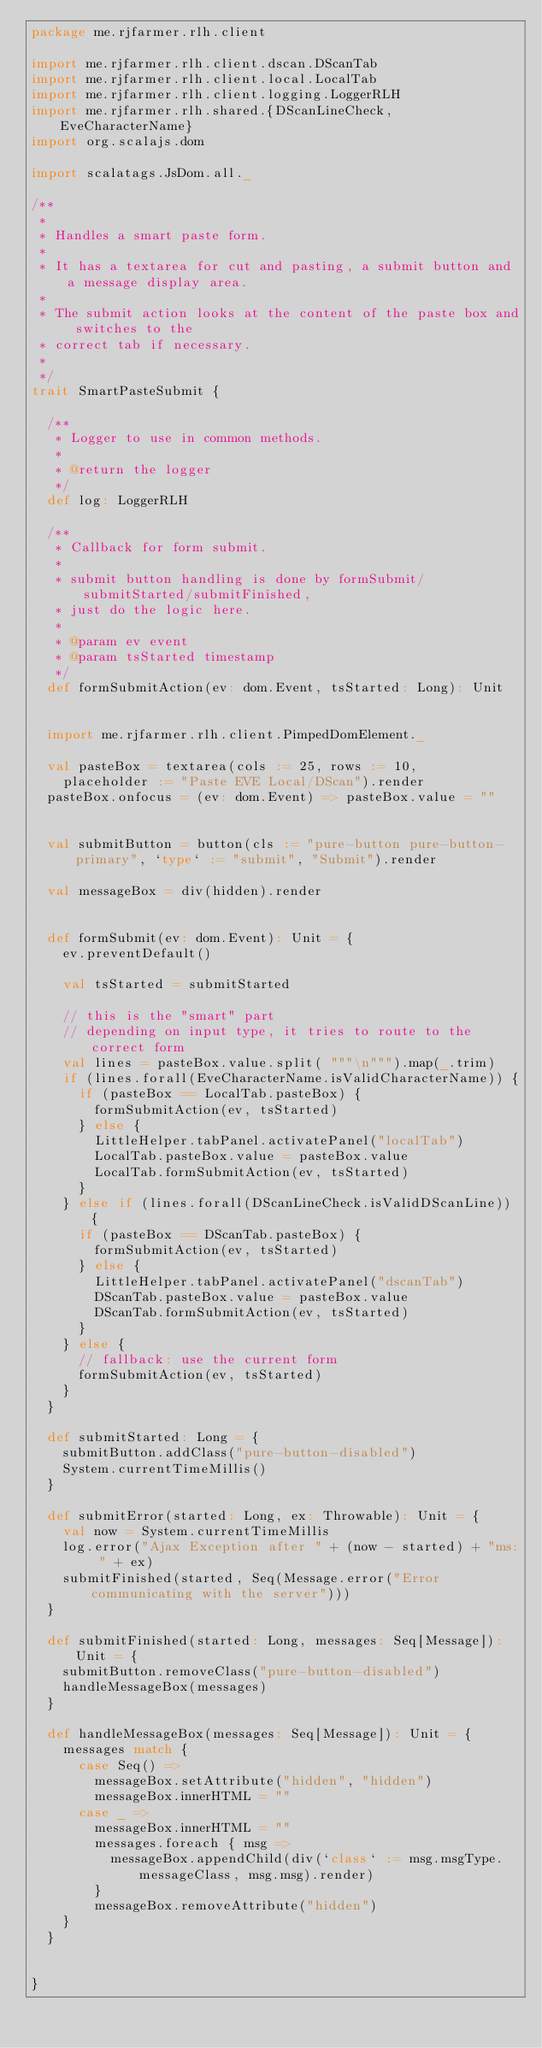<code> <loc_0><loc_0><loc_500><loc_500><_Scala_>package me.rjfarmer.rlh.client

import me.rjfarmer.rlh.client.dscan.DScanTab
import me.rjfarmer.rlh.client.local.LocalTab
import me.rjfarmer.rlh.client.logging.LoggerRLH
import me.rjfarmer.rlh.shared.{DScanLineCheck, EveCharacterName}
import org.scalajs.dom

import scalatags.JsDom.all._

/**
 *
 * Handles a smart paste form.
 *
 * It has a textarea for cut and pasting, a submit button and a message display area.
 *
 * The submit action looks at the content of the paste box and switches to the
 * correct tab if necessary.
 *
 */
trait SmartPasteSubmit {

  /**
   * Logger to use in common methods.
   *
   * @return the logger
   */
  def log: LoggerRLH

  /**
   * Callback for form submit.
   *
   * submit button handling is done by formSubmit/submitStarted/submitFinished,
   * just do the logic here.
   *
   * @param ev event
   * @param tsStarted timestamp
   */
  def formSubmitAction(ev: dom.Event, tsStarted: Long): Unit


  import me.rjfarmer.rlh.client.PimpedDomElement._

  val pasteBox = textarea(cols := 25, rows := 10,
    placeholder := "Paste EVE Local/DScan").render
  pasteBox.onfocus = (ev: dom.Event) => pasteBox.value = ""


  val submitButton = button(cls := "pure-button pure-button-primary", `type` := "submit", "Submit").render

  val messageBox = div(hidden).render


  def formSubmit(ev: dom.Event): Unit = {
    ev.preventDefault()

    val tsStarted = submitStarted

    // this is the "smart" part
    // depending on input type, it tries to route to the correct form
    val lines = pasteBox.value.split( """\n""").map(_.trim)
    if (lines.forall(EveCharacterName.isValidCharacterName)) {
      if (pasteBox == LocalTab.pasteBox) {
        formSubmitAction(ev, tsStarted)
      } else {
        LittleHelper.tabPanel.activatePanel("localTab")
        LocalTab.pasteBox.value = pasteBox.value
        LocalTab.formSubmitAction(ev, tsStarted)
      }
    } else if (lines.forall(DScanLineCheck.isValidDScanLine)) {
      if (pasteBox == DScanTab.pasteBox) {
        formSubmitAction(ev, tsStarted)
      } else {
        LittleHelper.tabPanel.activatePanel("dscanTab")
        DScanTab.pasteBox.value = pasteBox.value
        DScanTab.formSubmitAction(ev, tsStarted)
      }
    } else {
      // fallback: use the current form
      formSubmitAction(ev, tsStarted)
    }
  }

  def submitStarted: Long = {
    submitButton.addClass("pure-button-disabled")
    System.currentTimeMillis()
  }

  def submitError(started: Long, ex: Throwable): Unit = {
    val now = System.currentTimeMillis
    log.error("Ajax Exception after " + (now - started) + "ms: " + ex)
    submitFinished(started, Seq(Message.error("Error communicating with the server")))
  }

  def submitFinished(started: Long, messages: Seq[Message]): Unit = {
    submitButton.removeClass("pure-button-disabled")
    handleMessageBox(messages)
  }

  def handleMessageBox(messages: Seq[Message]): Unit = {
    messages match {
      case Seq() =>
        messageBox.setAttribute("hidden", "hidden")
        messageBox.innerHTML = ""
      case _ =>
        messageBox.innerHTML = ""
        messages.foreach { msg =>
          messageBox.appendChild(div(`class` := msg.msgType.messageClass, msg.msg).render)
        }
        messageBox.removeAttribute("hidden")
    }
  }


}
</code> 